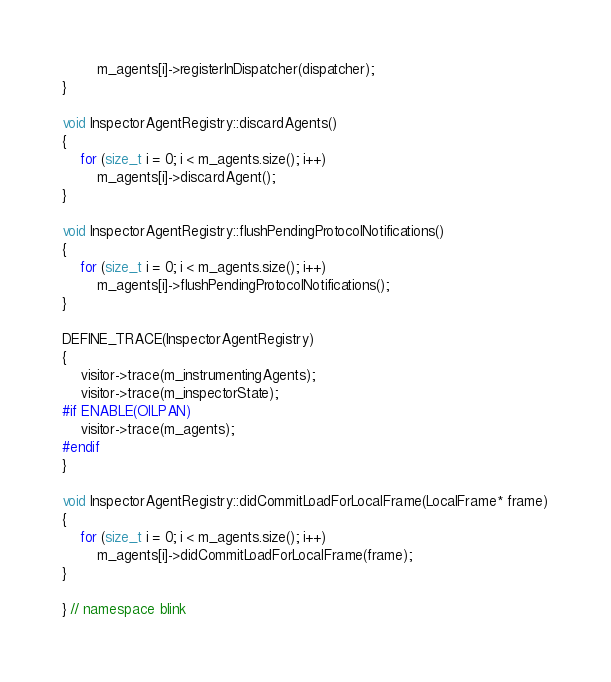Convert code to text. <code><loc_0><loc_0><loc_500><loc_500><_C++_>        m_agents[i]->registerInDispatcher(dispatcher);
}

void InspectorAgentRegistry::discardAgents()
{
    for (size_t i = 0; i < m_agents.size(); i++)
        m_agents[i]->discardAgent();
}

void InspectorAgentRegistry::flushPendingProtocolNotifications()
{
    for (size_t i = 0; i < m_agents.size(); i++)
        m_agents[i]->flushPendingProtocolNotifications();
}

DEFINE_TRACE(InspectorAgentRegistry)
{
    visitor->trace(m_instrumentingAgents);
    visitor->trace(m_inspectorState);
#if ENABLE(OILPAN)
    visitor->trace(m_agents);
#endif
}

void InspectorAgentRegistry::didCommitLoadForLocalFrame(LocalFrame* frame)
{
    for (size_t i = 0; i < m_agents.size(); i++)
        m_agents[i]->didCommitLoadForLocalFrame(frame);
}

} // namespace blink

</code> 